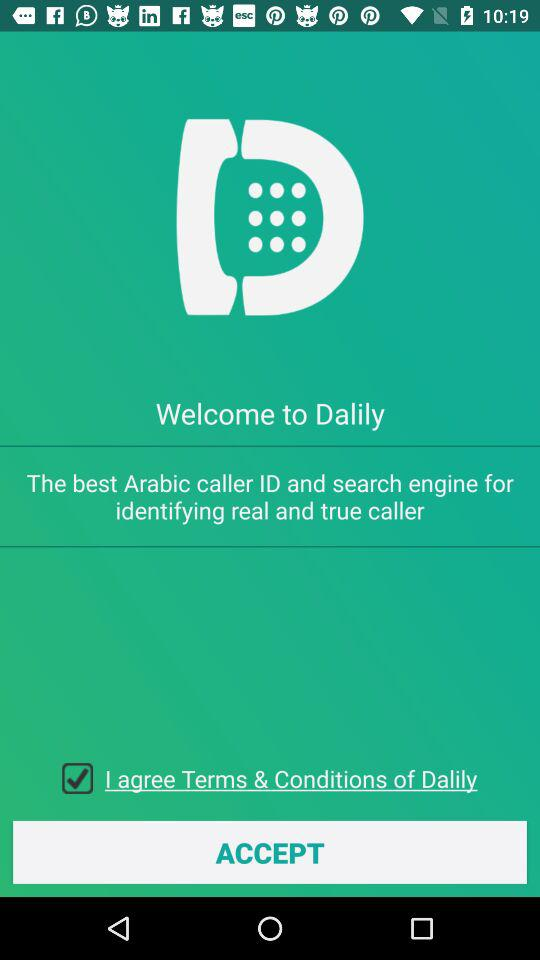What is the name of the application? The name of the application is "Dalily". 